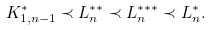<formula> <loc_0><loc_0><loc_500><loc_500>K ^ { * } _ { 1 , n - 1 } \prec L _ { n } ^ { * * } \prec L _ { n } ^ { * * * } \prec L ^ { * } _ { n } .</formula> 